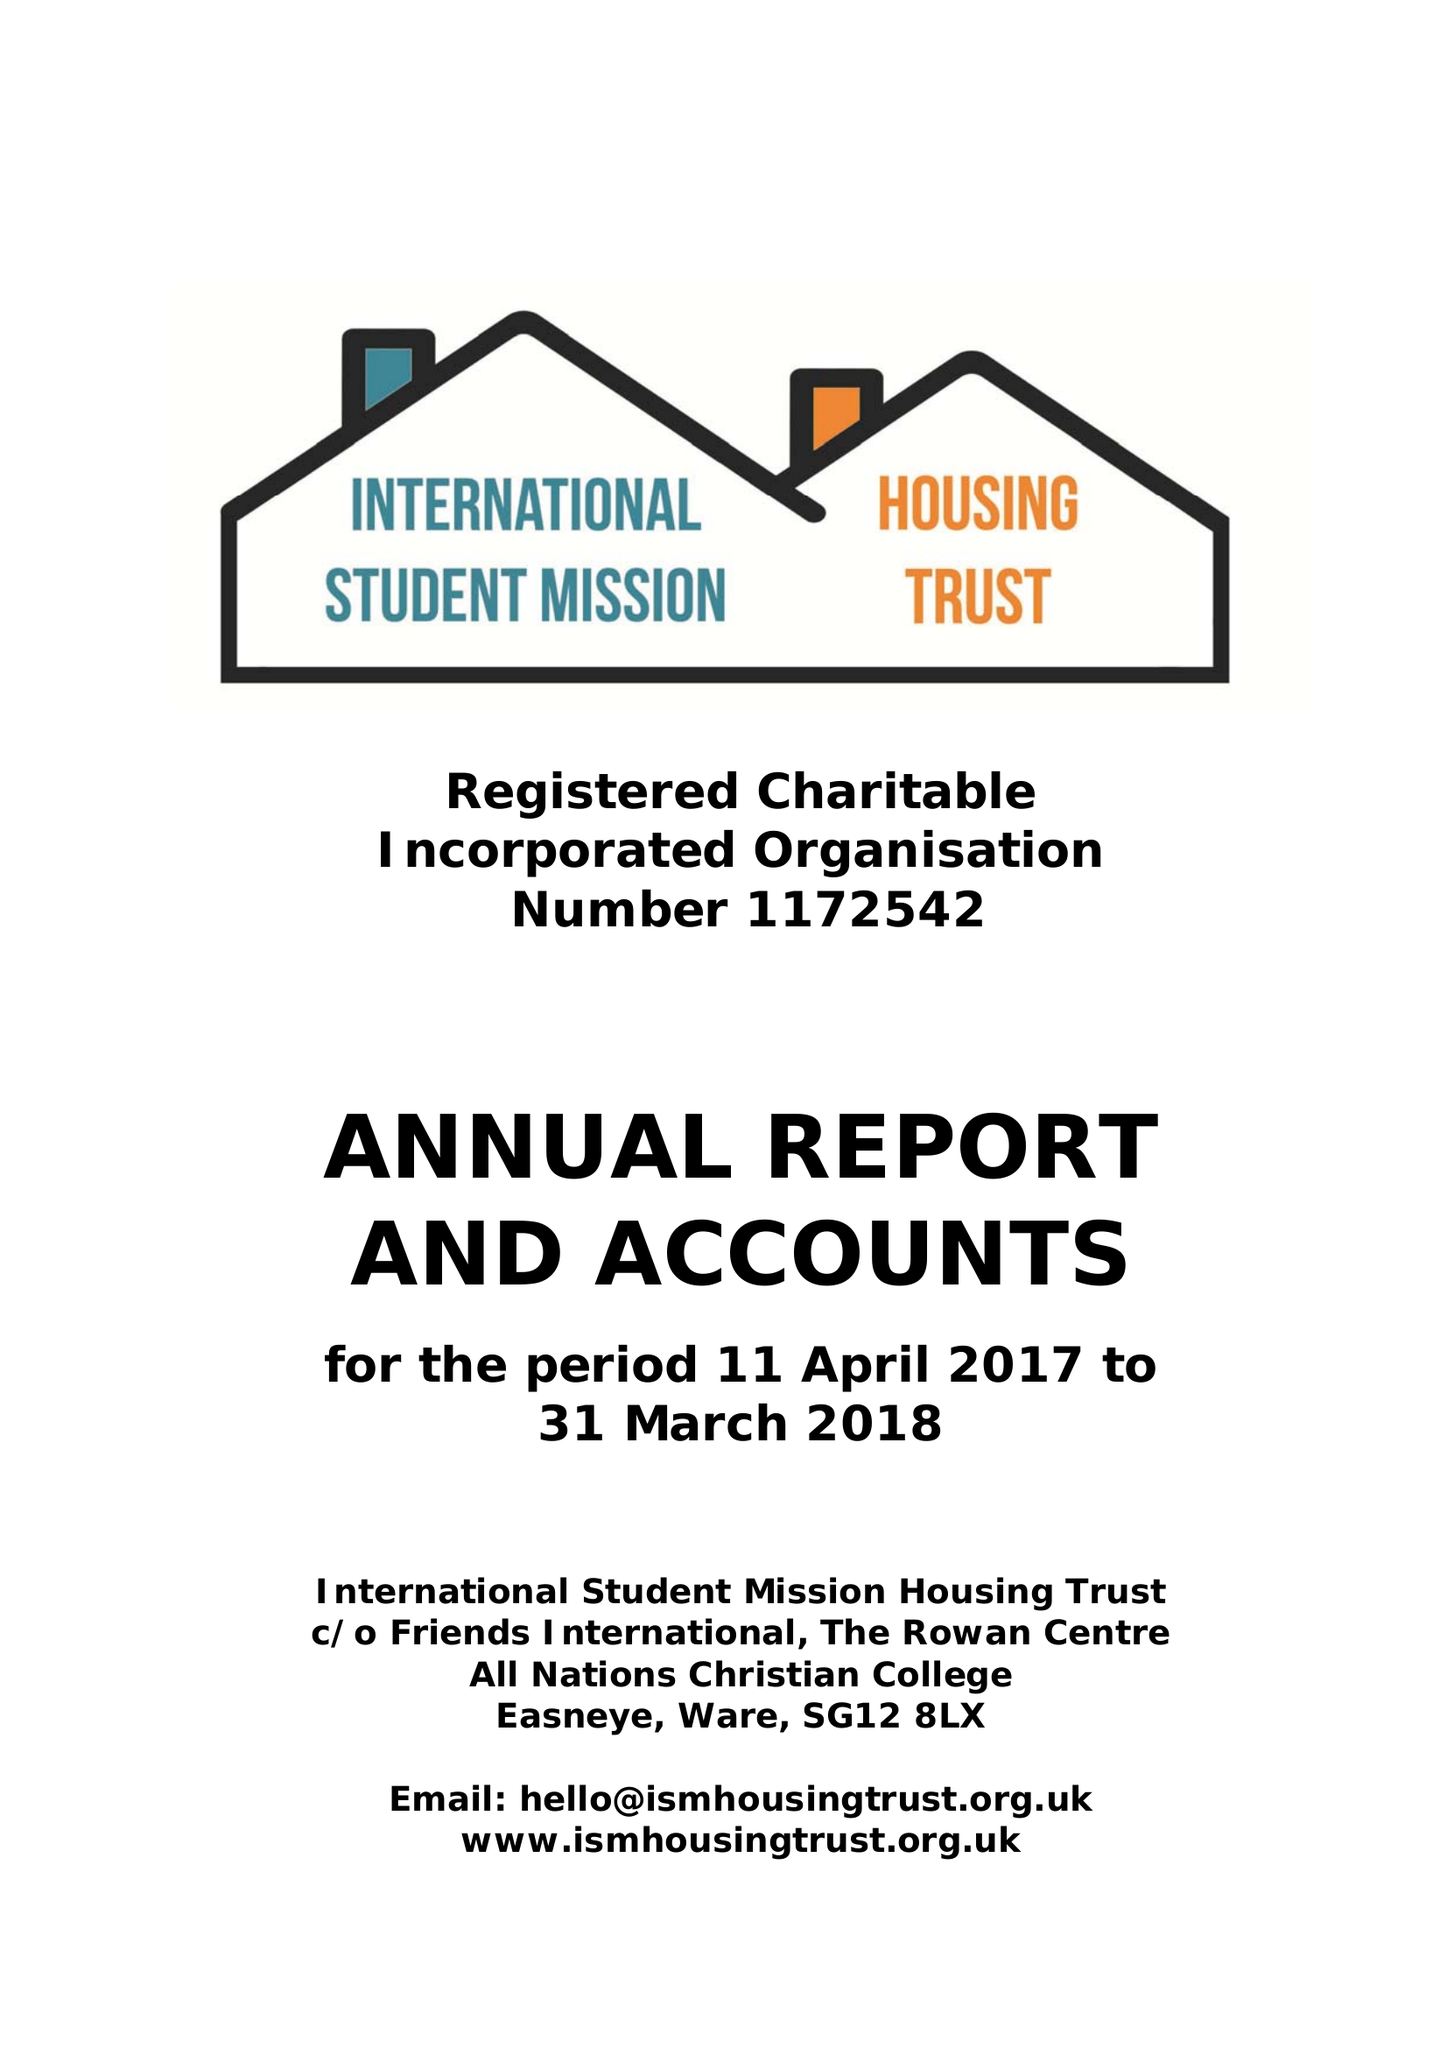What is the value for the address__postcode?
Answer the question using a single word or phrase. SG12 8LX 